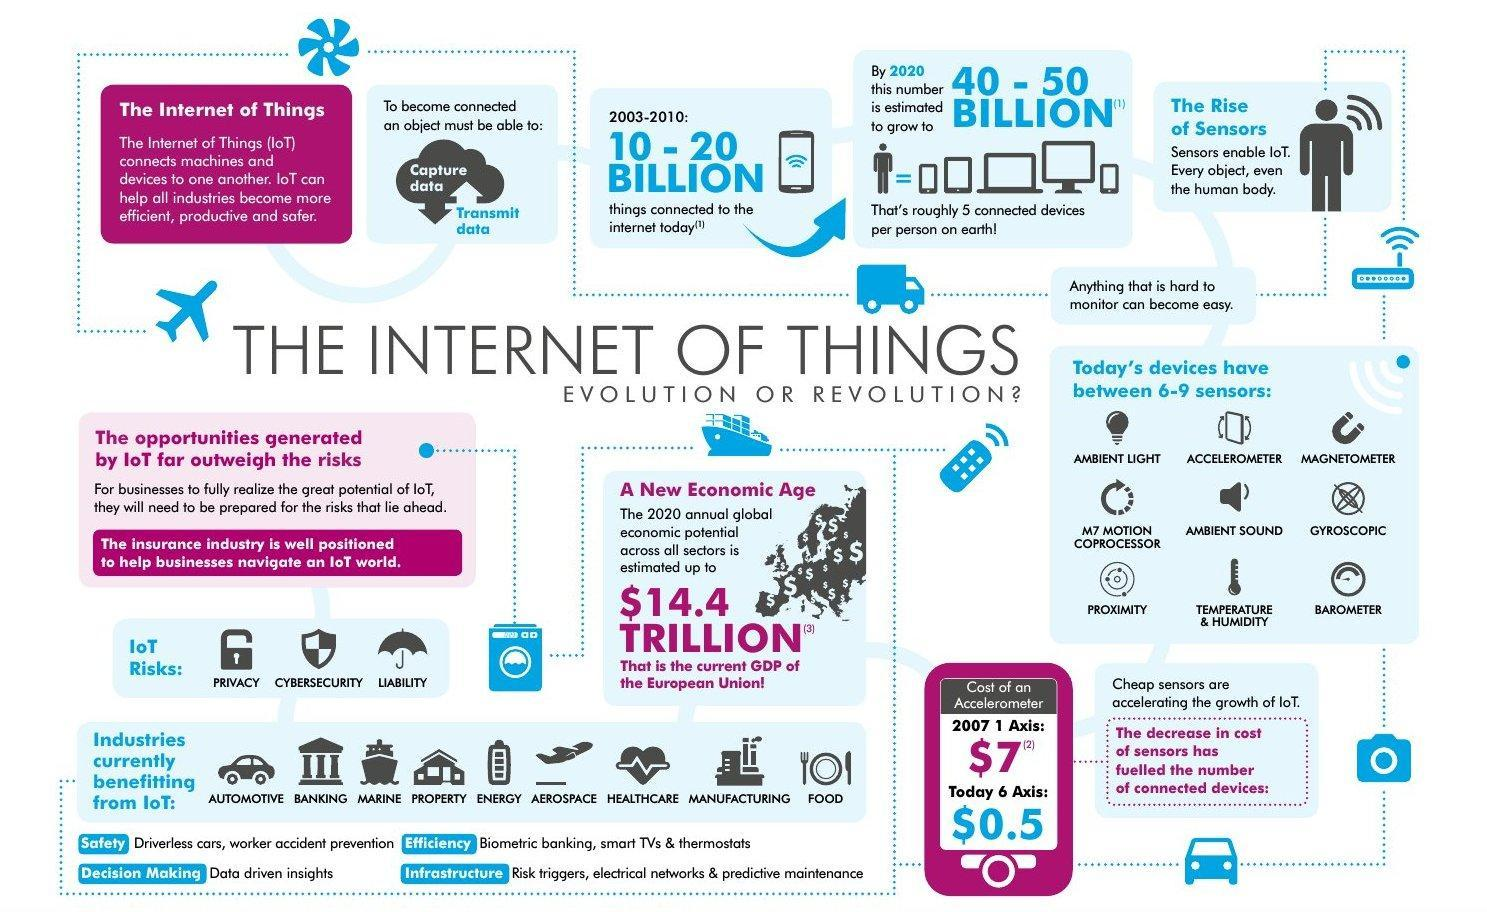name the sixth industry which is currently benefiting from internet of things?
Answer the question with a short phrase. aerospace which is the second last industry which is currently benefitting from the internet of things? manufacturing how many billion things are connected to the internet from over a period of seven years from 2003, 10-20 billion or 40 -50 billion? 10-20 billion from the list of sensors given in the infographic, name the sensor which is shown in second row second one? ambient sound 